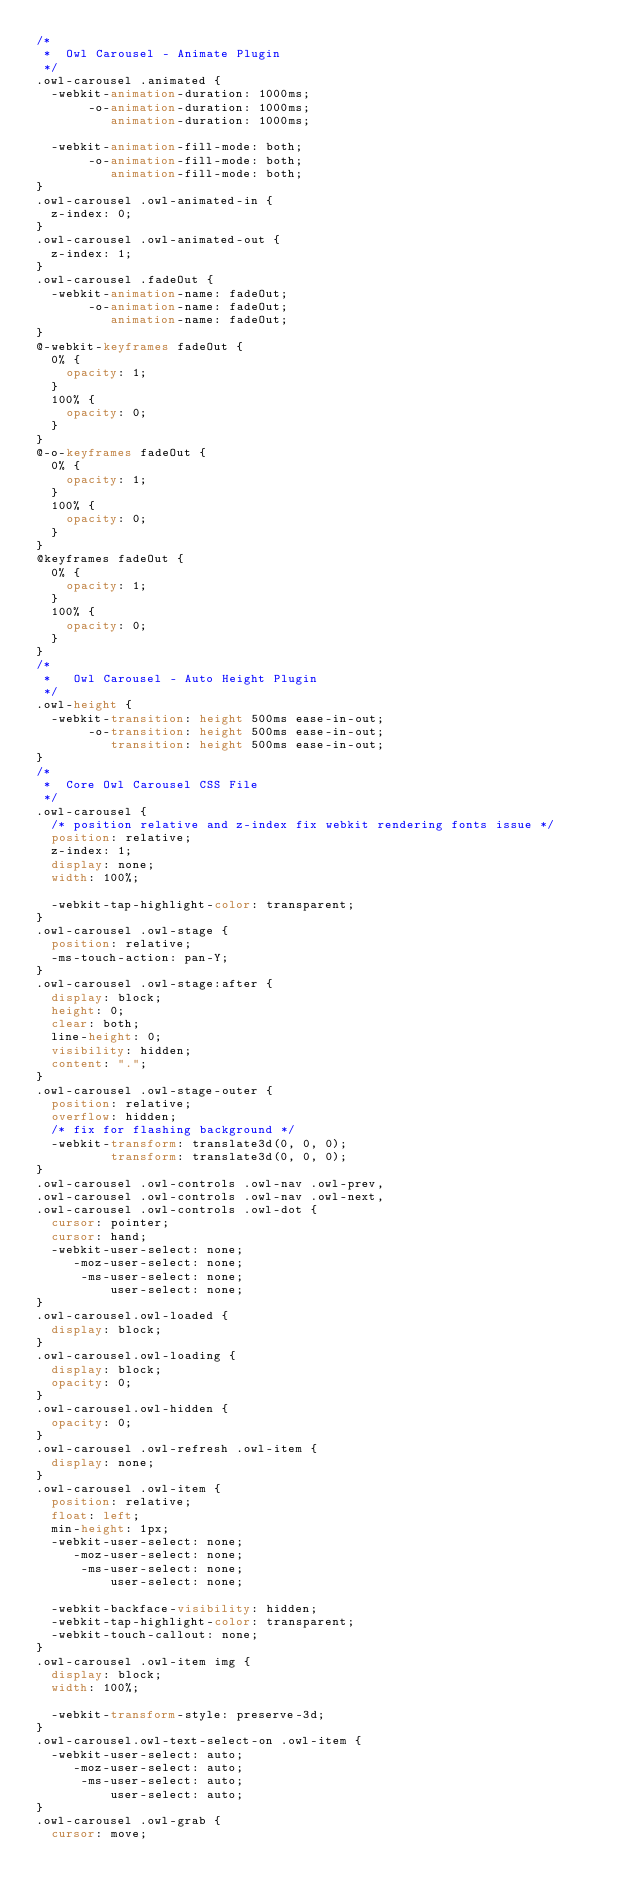<code> <loc_0><loc_0><loc_500><loc_500><_CSS_>/*
 *  Owl Carousel - Animate Plugin
 */
.owl-carousel .animated {
  -webkit-animation-duration: 1000ms;
       -o-animation-duration: 1000ms;
          animation-duration: 1000ms;

  -webkit-animation-fill-mode: both;
       -o-animation-fill-mode: both;
          animation-fill-mode: both;
}
.owl-carousel .owl-animated-in {
  z-index: 0;
}
.owl-carousel .owl-animated-out {
  z-index: 1;
}
.owl-carousel .fadeOut {
  -webkit-animation-name: fadeOut;
       -o-animation-name: fadeOut;
          animation-name: fadeOut;
}
@-webkit-keyframes fadeOut {
  0% {
    opacity: 1;
  }
  100% {
    opacity: 0;
  }
}
@-o-keyframes fadeOut {
  0% {
    opacity: 1;
  }
  100% {
    opacity: 0;
  }
}
@keyframes fadeOut {
  0% {
    opacity: 1;
  }
  100% {
    opacity: 0;
  }
}
/*
 *   Owl Carousel - Auto Height Plugin
 */
.owl-height {
  -webkit-transition: height 500ms ease-in-out;
       -o-transition: height 500ms ease-in-out;
          transition: height 500ms ease-in-out;
}
/*
 *  Core Owl Carousel CSS File
 */
.owl-carousel {
  /* position relative and z-index fix webkit rendering fonts issue */
  position: relative;
  z-index: 1;
  display: none;
  width: 100%;

  -webkit-tap-highlight-color: transparent;
}
.owl-carousel .owl-stage {
  position: relative;
  -ms-touch-action: pan-Y;
}
.owl-carousel .owl-stage:after {
  display: block;
  height: 0;
  clear: both;
  line-height: 0;
  visibility: hidden;
  content: ".";
}
.owl-carousel .owl-stage-outer {
  position: relative;
  overflow: hidden;
  /* fix for flashing background */
  -webkit-transform: translate3d(0, 0, 0);
          transform: translate3d(0, 0, 0);
}
.owl-carousel .owl-controls .owl-nav .owl-prev,
.owl-carousel .owl-controls .owl-nav .owl-next,
.owl-carousel .owl-controls .owl-dot {
  cursor: pointer;
  cursor: hand;
  -webkit-user-select: none;
     -moz-user-select: none;
      -ms-user-select: none;
          user-select: none;
}
.owl-carousel.owl-loaded {
  display: block;
}
.owl-carousel.owl-loading {
  display: block;
  opacity: 0;
}
.owl-carousel.owl-hidden {
  opacity: 0;
}
.owl-carousel .owl-refresh .owl-item {
  display: none;
}
.owl-carousel .owl-item {
  position: relative;
  float: left;
  min-height: 1px;
  -webkit-user-select: none;
     -moz-user-select: none;
      -ms-user-select: none;
          user-select: none;

  -webkit-backface-visibility: hidden;
  -webkit-tap-highlight-color: transparent;
  -webkit-touch-callout: none;
}
.owl-carousel .owl-item img {
  display: block;
  width: 100%;

  -webkit-transform-style: preserve-3d;
}
.owl-carousel.owl-text-select-on .owl-item {
  -webkit-user-select: auto;
     -moz-user-select: auto;
      -ms-user-select: auto;
          user-select: auto;
}
.owl-carousel .owl-grab {
  cursor: move;</code> 